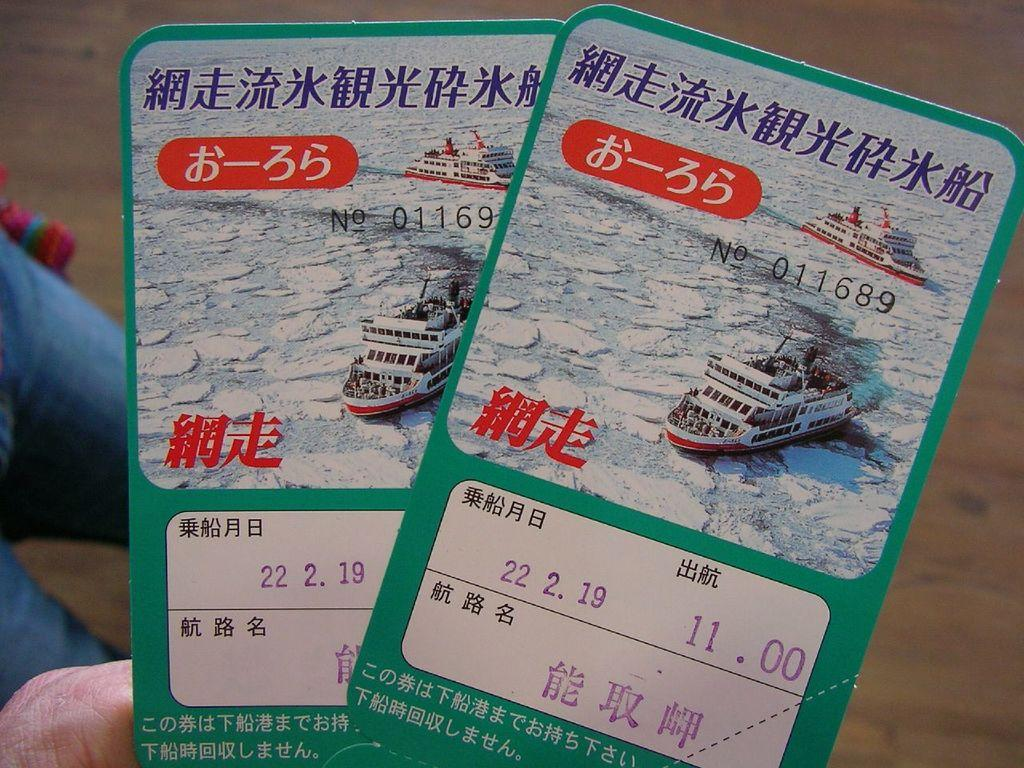Who is present in the image? There is a person in the image. What is the person holding in the image? The person is holding two tickets. What is the surface that the person is standing on in the image? There is a floor visible at the bottom of the image. How does the person react to the comparison between the two tickets in the image? There is no comparison between the two tickets mentioned in the image, so it is not possible to determine the person's reaction. 